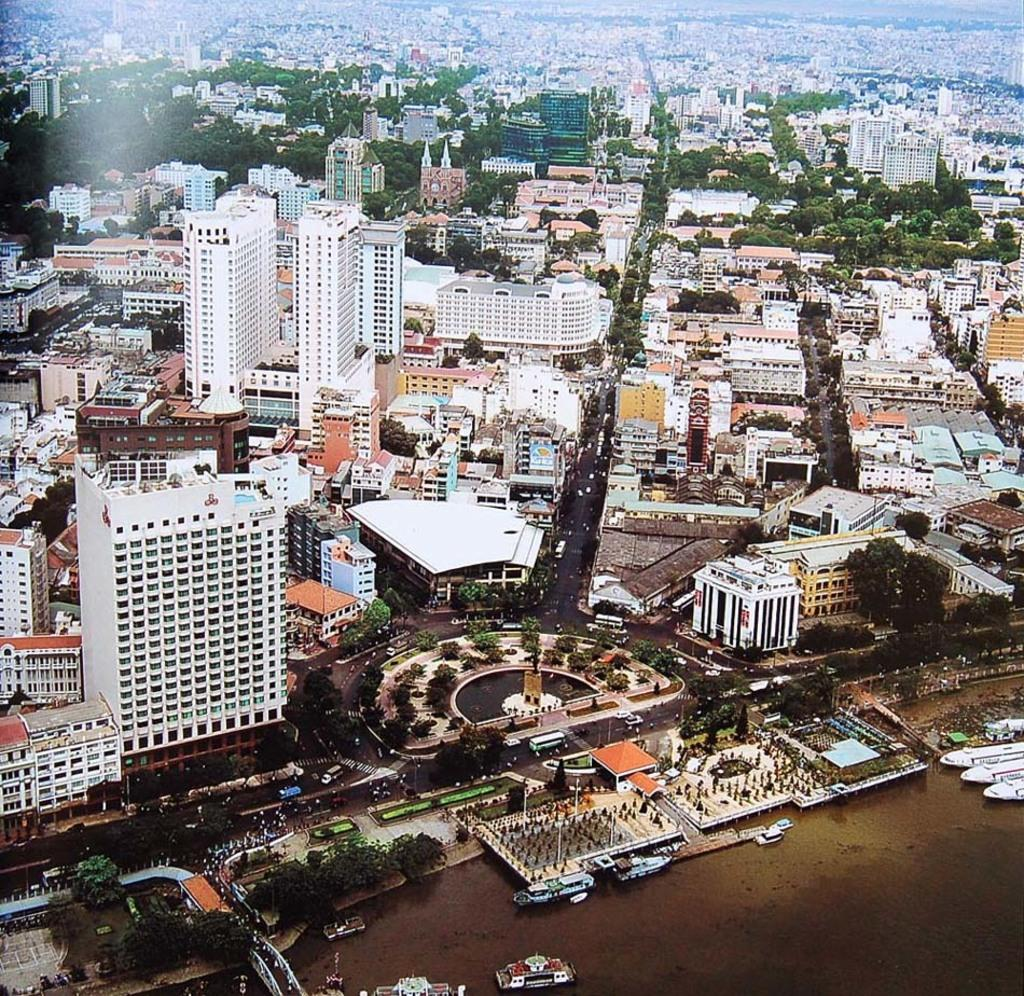What is positioned above the water in the image? There are boats above the water in the image. What type of structures can be seen in the image? There are buildings visible in the image. What type of vegetation is present in the image? Trees are present in the image. What type of vertical structures can be seen in the image? Poles are visible in the image. What type of transportation is on the road in the image? Vehicles are on the road in the image. Can you hear the crib laughing in the image? There is no crib present in the image, and therefore no such activity can be observed. 